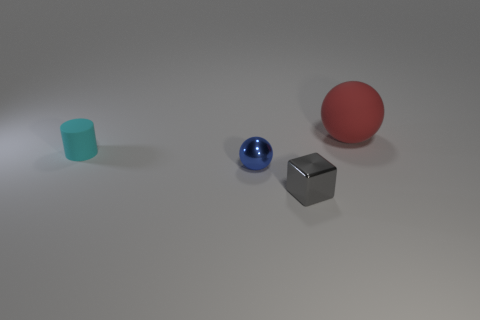Add 1 tiny gray matte balls. How many objects exist? 5 Subtract all cylinders. How many objects are left? 3 Add 2 blue rubber cylinders. How many blue rubber cylinders exist? 2 Subtract 0 purple blocks. How many objects are left? 4 Subtract all large green metallic objects. Subtract all cyan matte things. How many objects are left? 3 Add 1 cyan cylinders. How many cyan cylinders are left? 2 